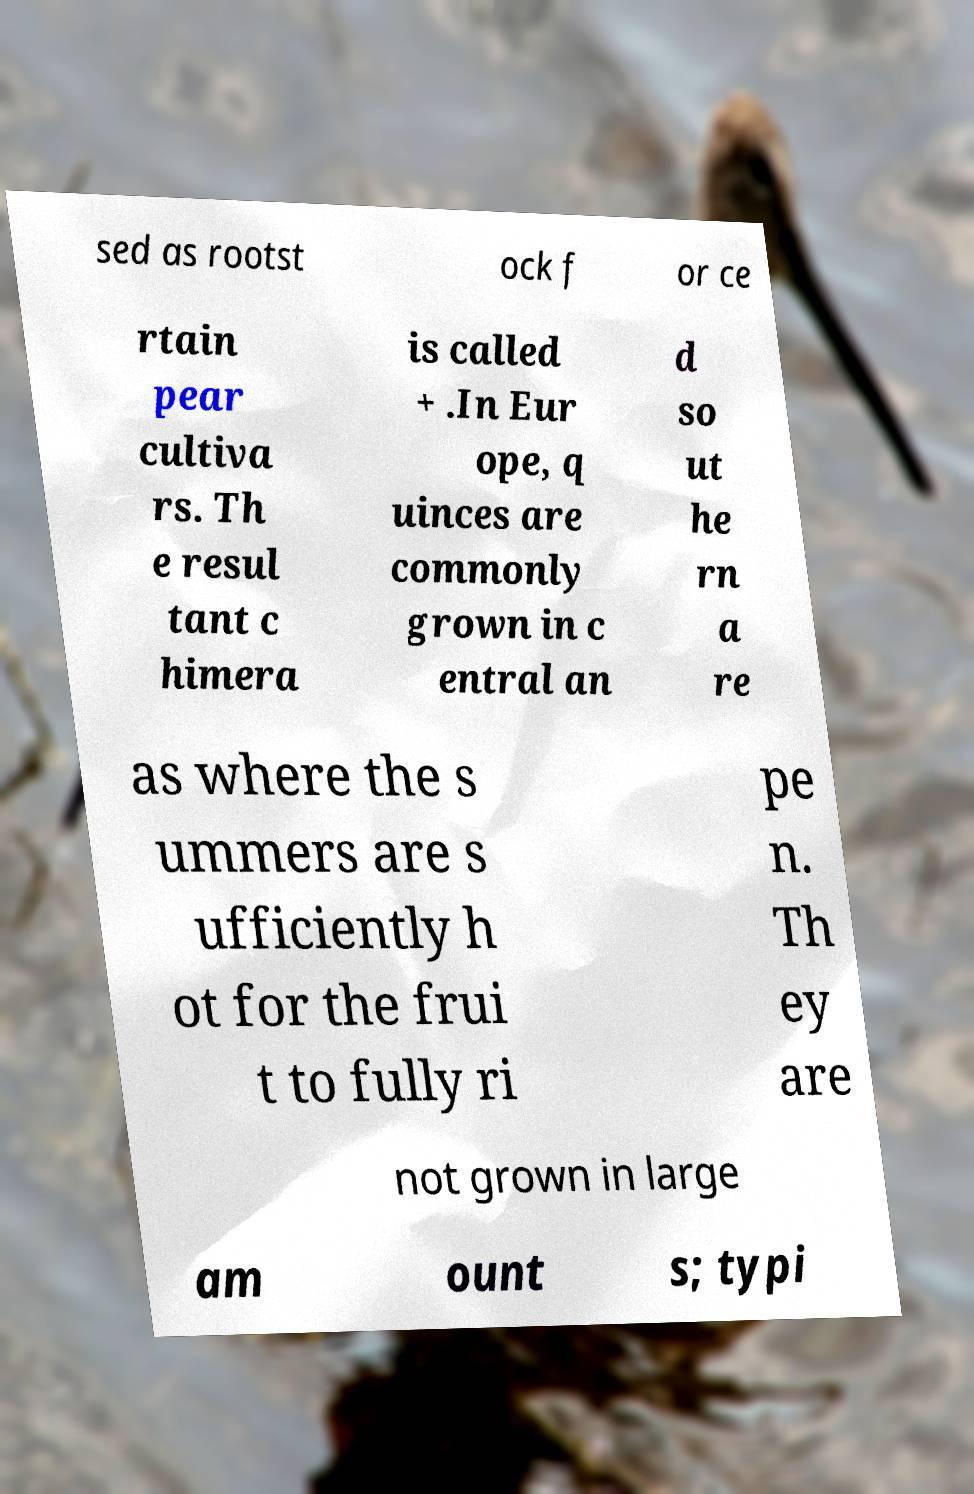There's text embedded in this image that I need extracted. Can you transcribe it verbatim? sed as rootst ock f or ce rtain pear cultiva rs. Th e resul tant c himera is called + .In Eur ope, q uinces are commonly grown in c entral an d so ut he rn a re as where the s ummers are s ufficiently h ot for the frui t to fully ri pe n. Th ey are not grown in large am ount s; typi 